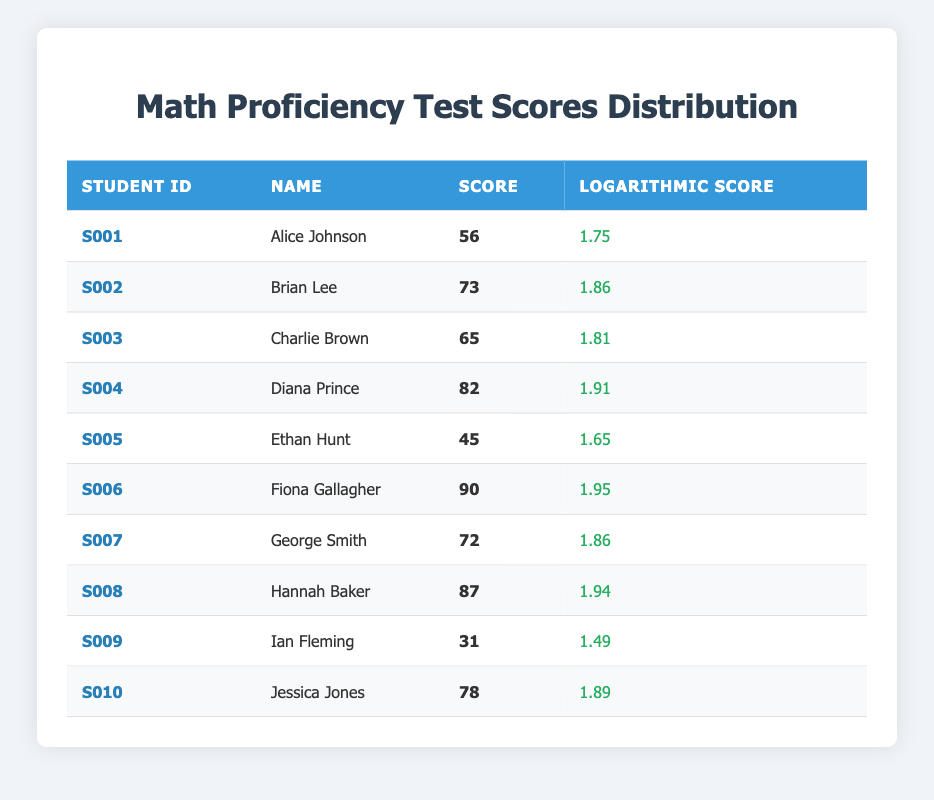What is the highest score in the table? The table indicates the scores for each student. I look through the 'Score' column and see that the highest value is 90, from Fiona Gallagher.
Answer: 90 Who is the student with the lowest score? I check the 'Score' column to identify the lowest value. The lowest score is 31, which belongs to Ian Fleming.
Answer: Ian Fleming What is the average score of all students listed? First, I sum all the scores: 56 + 73 + 65 + 82 + 45 + 90 + 72 + 87 + 31 + 78 =  708. There are 10 students, so I divide 708 by 10 to get an average of 70.8.
Answer: 70.8 Is Jessica Jones's score above average? I've found that the average score is 70.8. Jessica Jones scored 78, which is above 70.8, confirming that her score is indeed above average.
Answer: Yes What is the difference between the highest and lowest logarithmic scores? The highest logarithmic score is from Fiona Gallagher, which is 1.95. The lowest is from Ian Fleming at 1.49. So, I subtract: 1.95 - 1.49 = 0.46.
Answer: 0.46 How many students scored above 80? I examine the 'Score' column for values above 80. These scores belong to Diana Prince (82) and Fiona Gallagher (90), which counts to 2 students.
Answer: 2 Which student scored the second highest score, and what was it? I first identify the highest score (90 from Fiona Gallagher), then the next one is 87 from Hannah Baker, making her the second highest scorer.
Answer: Hannah Baker, 87 Are there more students with scores less than 60 than those with scores greater than 80? I check the scores: students with scores less than 60 are Ethan Hunt (45) and Ian Fleming (31), totaling 2 students. For scores greater than 80, 3 students (Diana Prince, Fiona Gallagher, and Hannah Baker) meet the criteria. Thus, there are more students with scores above 80.
Answer: No What is the median score of the students? I first list the scores in ascending order: 31, 45, 56, 65, 72, 73, 78, 82, 87, 90. There are 10 scores, so the median will be the average of the 5th and 6th scores: (72 + 73) / 2 = 72.5.
Answer: 72.5 